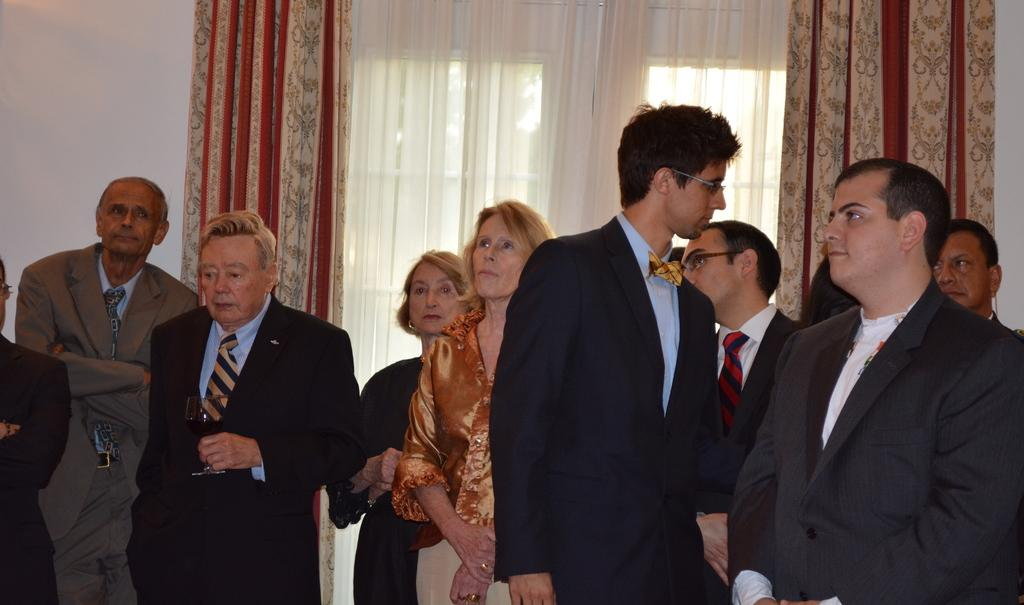How many people are in the image? There is a group of people in the image. What is one person holding in the image? One person is holding a glass. What can be seen in the background of the image? There are windows visible in the background, and curtains are present near the windows. What color is the wall in the background? There is a white wall in the background. How many cannons are visible in the image? There are no cannons present in the image. What type of card is being used by the people in the image? There is no card visible in the image. 